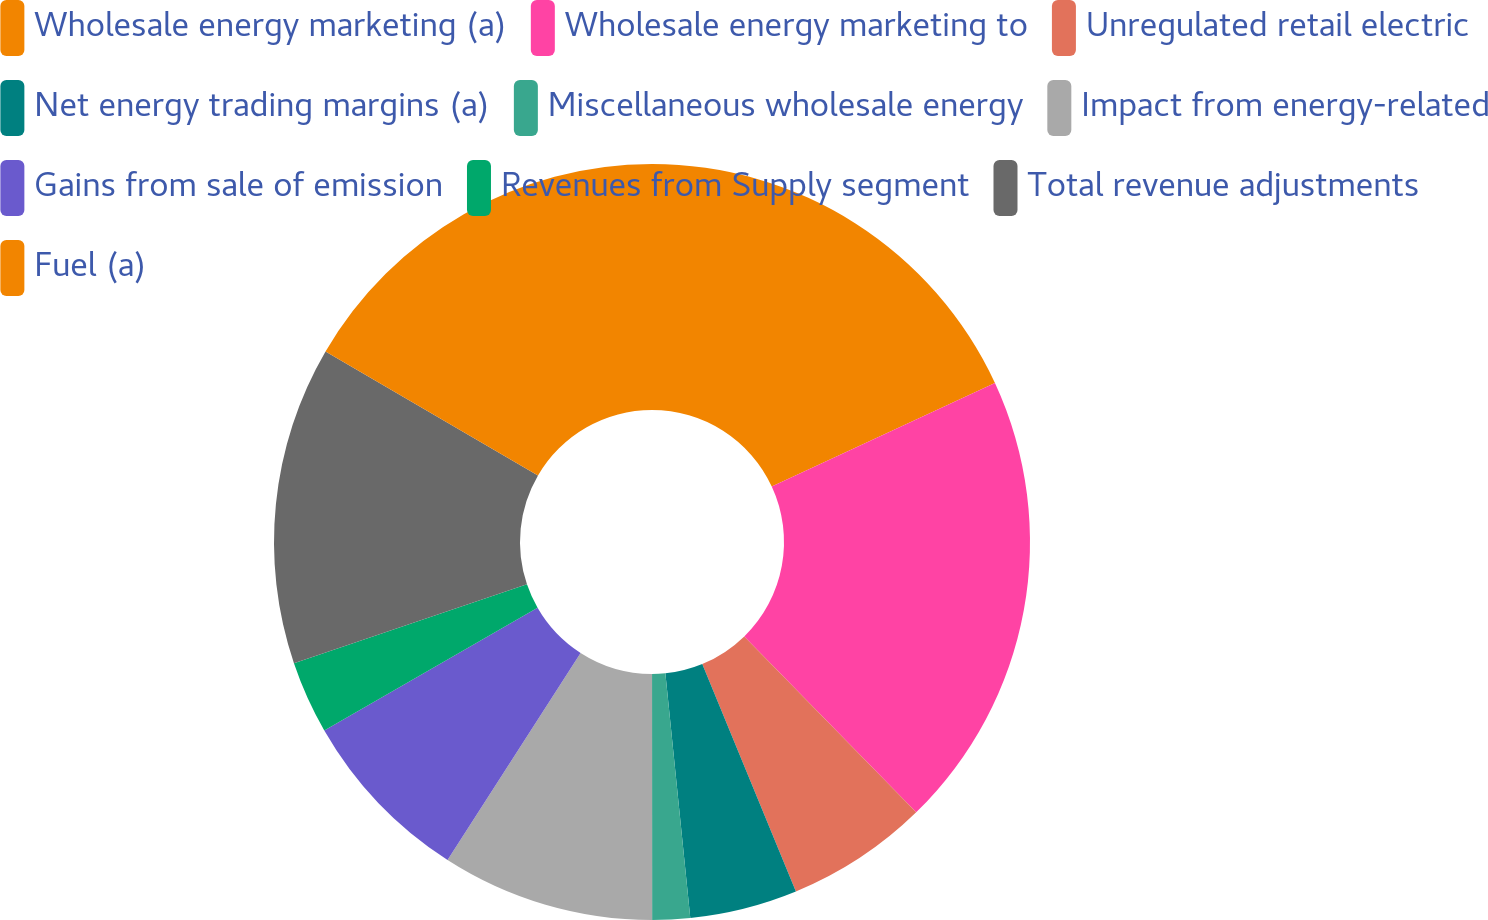<chart> <loc_0><loc_0><loc_500><loc_500><pie_chart><fcel>Wholesale energy marketing (a)<fcel>Wholesale energy marketing to<fcel>Unregulated retail electric<fcel>Net energy trading margins (a)<fcel>Miscellaneous wholesale energy<fcel>Impact from energy-related<fcel>Gains from sale of emission<fcel>Revenues from Supply segment<fcel>Total revenue adjustments<fcel>Fuel (a)<nl><fcel>18.09%<fcel>19.59%<fcel>6.1%<fcel>4.6%<fcel>1.61%<fcel>9.1%<fcel>7.6%<fcel>3.11%<fcel>13.6%<fcel>16.59%<nl></chart> 